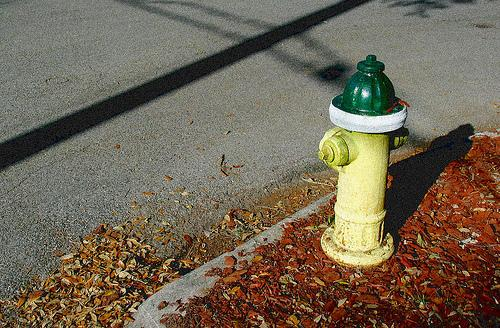What is the primary object in the image and its color? A green and yellow fire hydrant. What type of vegetation can be seen in the image? Green grass, a small sprig of grass beside the road, and leaves covering the ground and the sidewalk. What barriers are visible on the sidewalk in the image? A concrete sidewalk barrier can be seen. Identify the most noticeable aspect of the fire hydrant and the environment around it. The fire hydrant has a green top and a white trim, and it is situated on brown mulch. Describe any notable landscape or ground features present in the image. A pile of leaves on the pavement beside the sidewalk, mulch surrounding the fire hydrant, some leaves along the side of the sidewalk, and a few cracks on the pavement. Describe the scene involving the fire hydrant and its surroundings. A green, yellow, and white fire hydrant is located next to the street, surrounded by brown mulch with some small leaves on top of it, and casting a shadow on the ground. Mention any non-natural debris found in the image. There is a small stick and a circular crack on the pavement. Comment on the presence of shadows in the image. There are shadows on the street from the fire hydrant, an electric pole, and a tree. What details can be observed about the fire hydrant itself? The fire hydrant has a green top, white trim, and a green bolt on top, with a base covered in dirt and small leaves on top of it. Explain the condition of the sidewalk and the road in the image. The sidewalk and road are covered in leaves, with some green grass growing on the sidewalk and a few cracks on the pavement. List the colors and objects on the fire hydrant. Green, yellow, white, bolt, and green top Is the fire hydrant completely blue in color? No, it's not mentioned in the image. Is there a traffic light in the image casting a shadow on the street? Although there are shadows on the street from an electric pole and a tree, there is no mention of a shadow from a traffic light. Write a creative caption that captures the atmosphere of the scene. Amidst fallen leaves, a vibrant green and yellow fire hydrant stands guard on a bed of brown mulch. Identify any natural occurring elements that can be found as a main visual focus in the image. pile of leaves on the pavement and mulch surrounding the fire hydrant o What kind of pavement is there in the image? cracked pavement What is the fire hydrant standing on? brown mulch From the description, is the fire hydrant on grass or mulch? mulch Finish the following sentence based on the image: The fire hydrant has a green and yellow body with a _______________. white trim What object can be found on the road near the fire hydrant? small stick Where is the small sprig of green grass located in the image? beside the road Which parts of the fire hydrant are covered in dirt? base of hydrant Is there any grass growing on the sidewalk? Yes, green grass Articulate a possible narrative behind the creation of the shadow in the middle of the road. The sun casts a shadow from a tree and an electric pole across the cracked pavement, adding a contrasting element to the scene. Is there a concrete sidewalk barrier in the image? Yes What is the main material covering the ground? leaves and mulch Describe the facial features of the fire hydrant. There are no facial features on the fire hydrant. What is the main color of the fire hydrant? Green and yellow Create a descriptive caption for the fire hydrant. A green, yellow and white fire hydrant stands on brown mulch next to a sidewalk. Create a poetic caption for this scene. Standing tall and bright, the green and yellow fire hydrant emerges amidst fallen leaves and whispers of green. Identify the event occurring in the image related to shadows. shadow of a tree and an electric pole being cast on the road Based on the objects found in the image, what kind of environment is this scene taking place in? a sidewalk and street with fire hydrant and some vegetation 